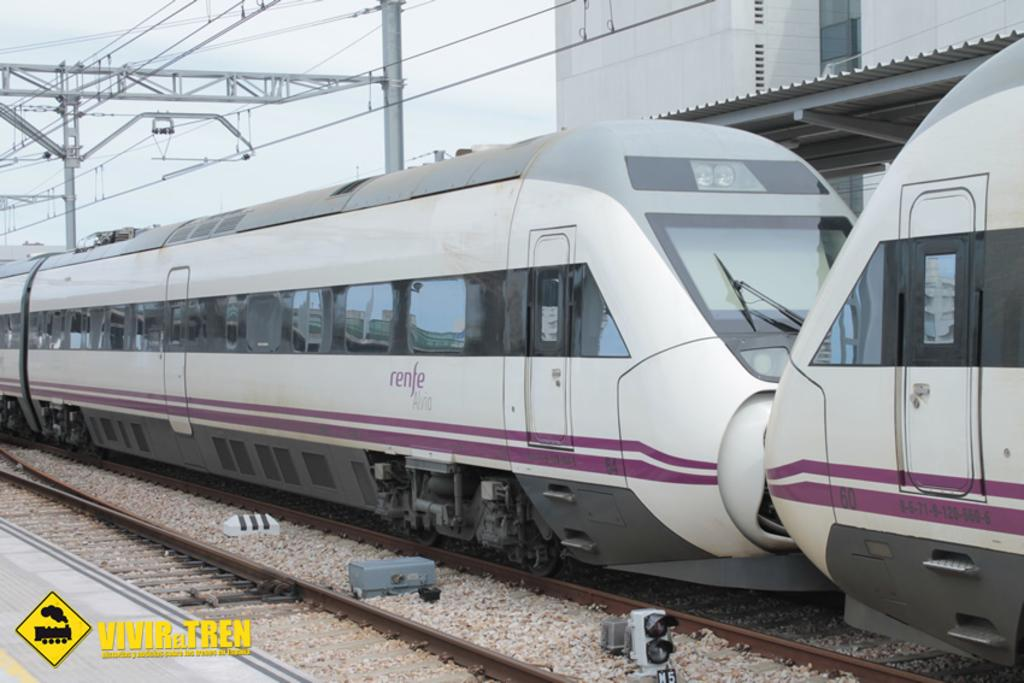What type of transportation is featured in the image? There is a metro in the image. What is the metro traveling on? There is a track in the image for the metro to travel on. What else can be seen in the image besides the metro and track? Current polls and a building are present in the image. What is visible in the background of the image? The sky is visible in the image. What color is the boy's sweater in the image? There is no boy or sweater present in the image. How many birds are perched on the metro in the image? There are no birds present in the image. 